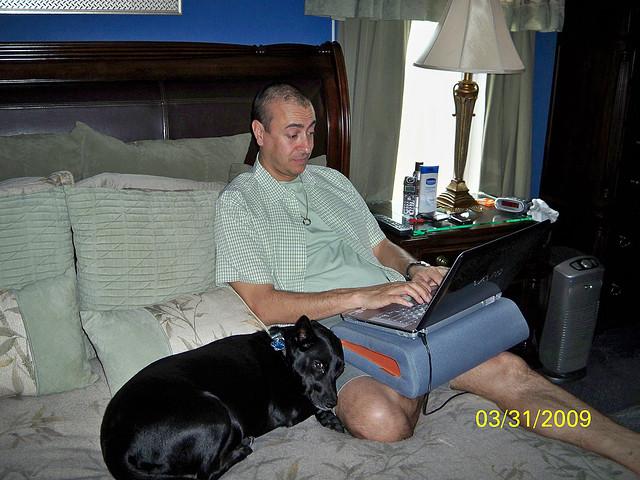What is behind the lamp shade?
Write a very short answer. Window. Is this man laying on the floor or a bed?
Answer briefly. Bed. Is the person alone on the furniture?
Short answer required. No. Why does the man look so stunned?
Write a very short answer. Computer. When was the photo taken?
Answer briefly. 03/31/2009. What is the man looking at?
Write a very short answer. Laptop. 